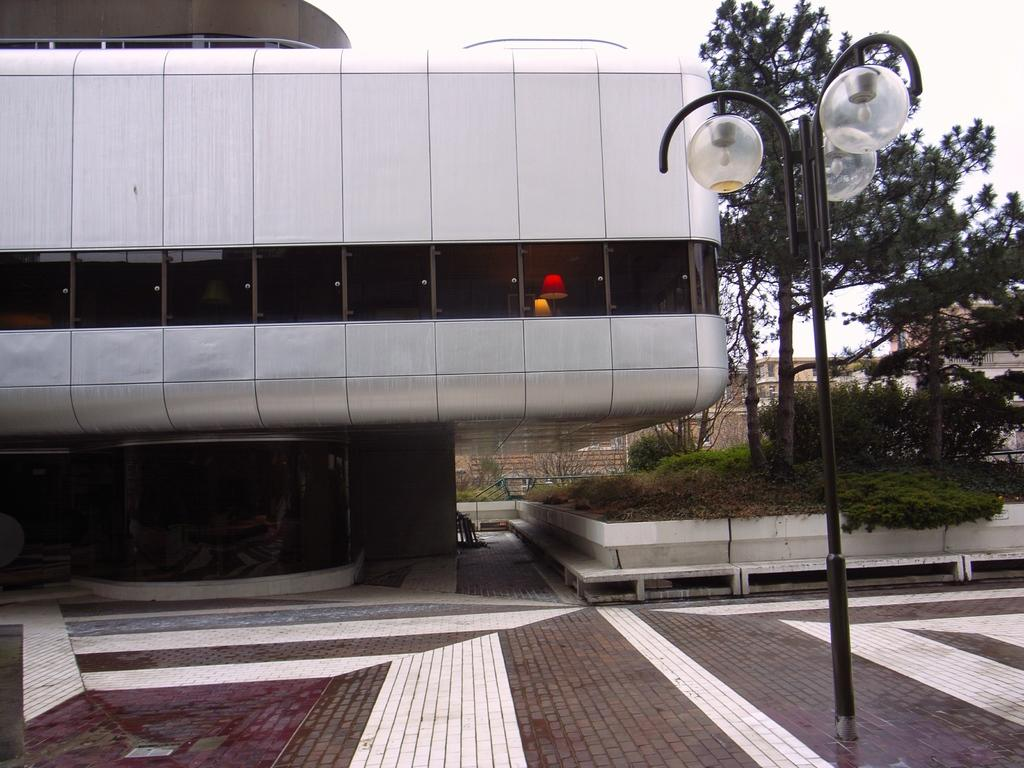What type of windows does the house in the image have? The house in the image has glass windows. What can be seen near the house? There are trees near the house. What is the purpose of the pole in the image? The pole in the image is a light pole. What can be seen in the distance behind the house? There are houses visible in the background. What is visible at the top of the image? The sky is visible at the top of the image. Where is the throne located in the image? There is no throne present in the image. What type of waves can be seen crashing against the shore in the image? There is no shore or waves present in the image. 